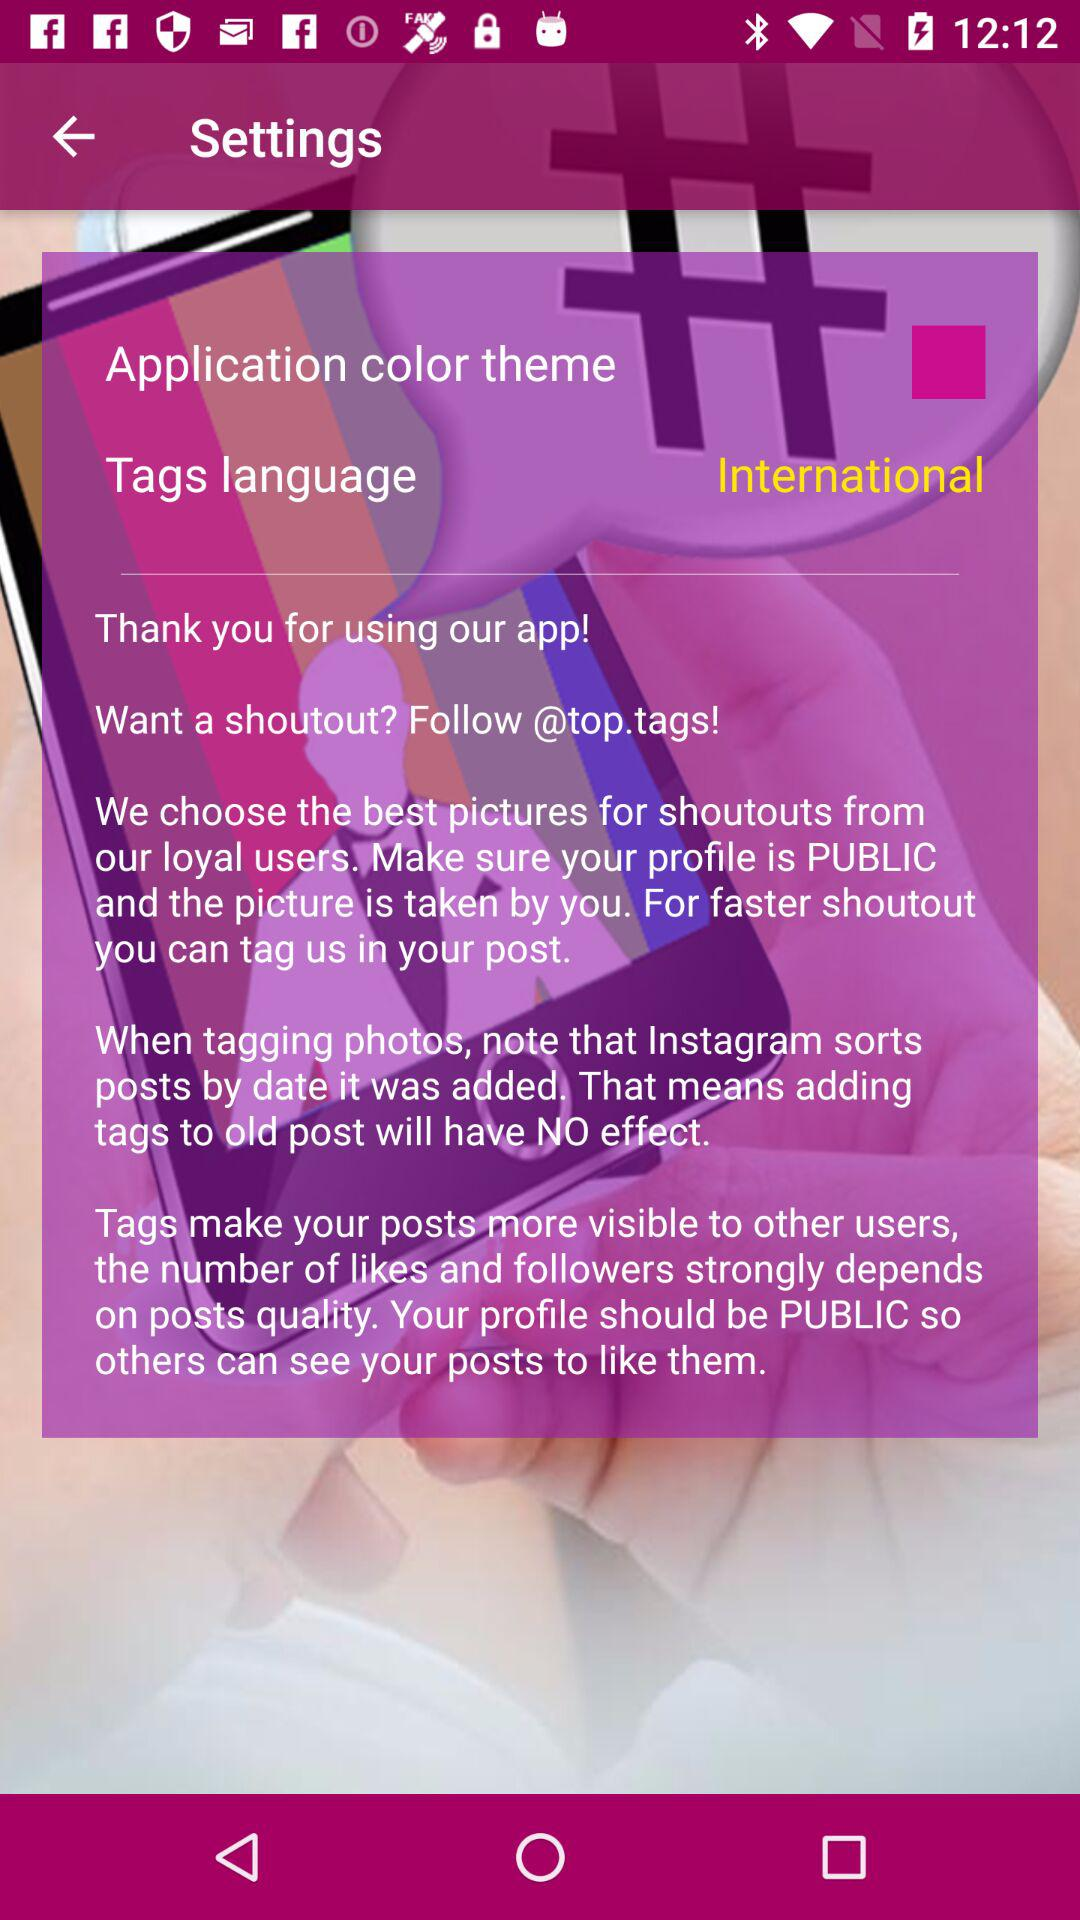What's the tag name to follow for a shoutout? The tag name to follow for a shoutout is "@top.tags!". 